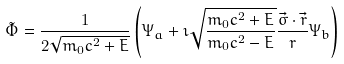<formula> <loc_0><loc_0><loc_500><loc_500>\tilde { \Phi } = \frac { 1 } { 2 \sqrt { m _ { 0 } c ^ { 2 } + E } } \left ( \Psi _ { a } + \imath \sqrt { \frac { m _ { 0 } c ^ { 2 } + E } { m _ { 0 } c ^ { 2 } - E } } \frac { \vec { \sigma } \cdot \vec { r } } { r } \Psi _ { b } \right )</formula> 